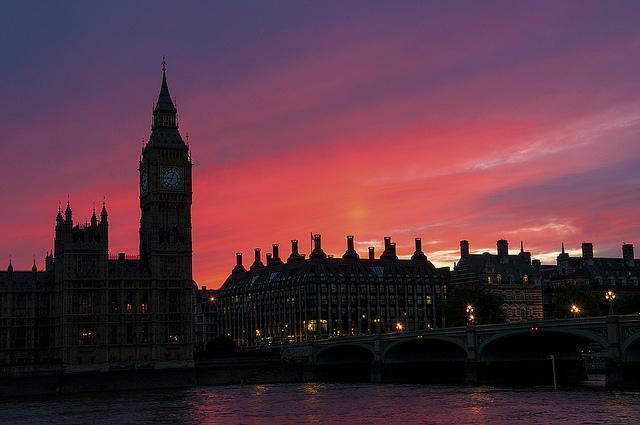How many elephant trunks can be seen?
Give a very brief answer. 0. 